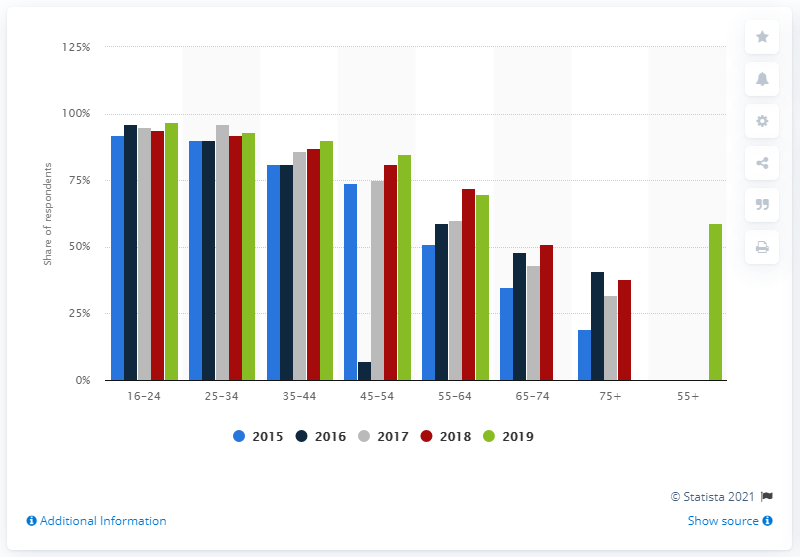Identify some key points in this picture. In the UK, in 2019, 93% of adults between the ages of 25 and 34 had their own social network profile. 